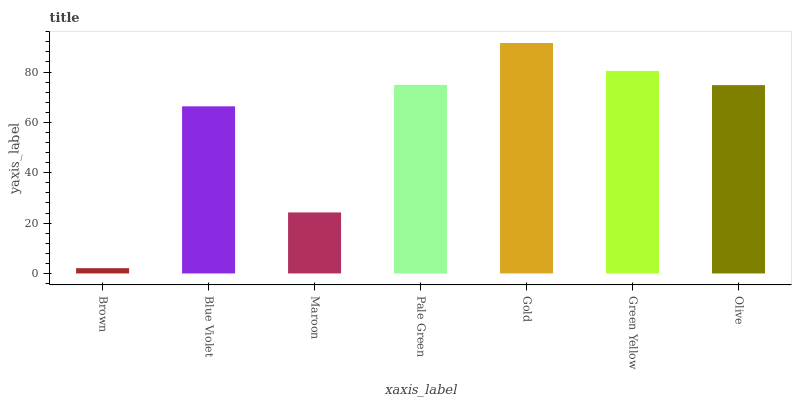Is Blue Violet the minimum?
Answer yes or no. No. Is Blue Violet the maximum?
Answer yes or no. No. Is Blue Violet greater than Brown?
Answer yes or no. Yes. Is Brown less than Blue Violet?
Answer yes or no. Yes. Is Brown greater than Blue Violet?
Answer yes or no. No. Is Blue Violet less than Brown?
Answer yes or no. No. Is Olive the high median?
Answer yes or no. Yes. Is Olive the low median?
Answer yes or no. Yes. Is Gold the high median?
Answer yes or no. No. Is Gold the low median?
Answer yes or no. No. 